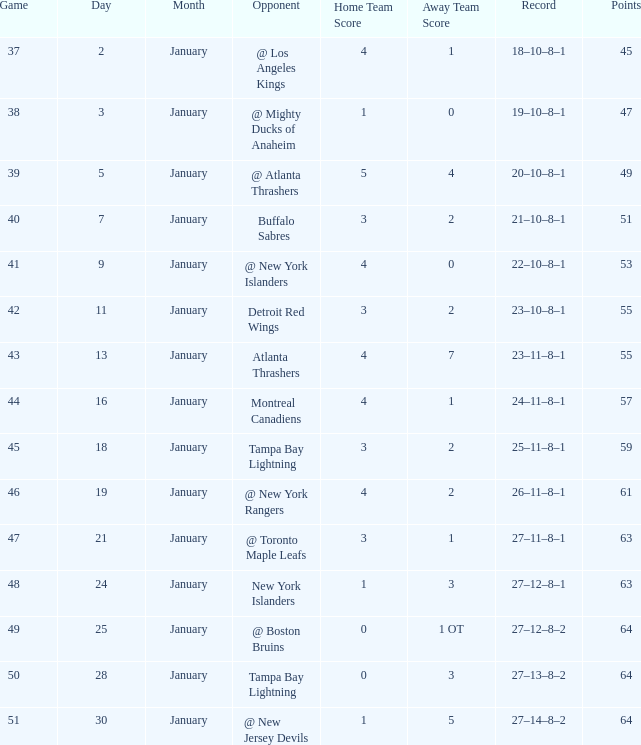Which score consists of 64 points and 49 games? 0–1 OT. 